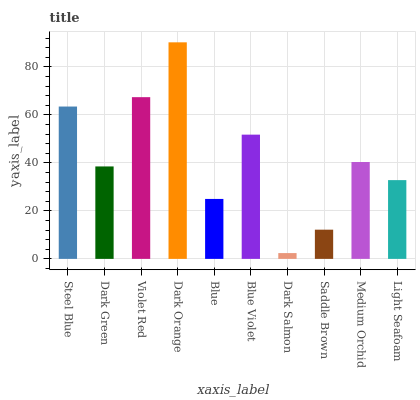Is Dark Salmon the minimum?
Answer yes or no. Yes. Is Dark Orange the maximum?
Answer yes or no. Yes. Is Dark Green the minimum?
Answer yes or no. No. Is Dark Green the maximum?
Answer yes or no. No. Is Steel Blue greater than Dark Green?
Answer yes or no. Yes. Is Dark Green less than Steel Blue?
Answer yes or no. Yes. Is Dark Green greater than Steel Blue?
Answer yes or no. No. Is Steel Blue less than Dark Green?
Answer yes or no. No. Is Medium Orchid the high median?
Answer yes or no. Yes. Is Dark Green the low median?
Answer yes or no. Yes. Is Violet Red the high median?
Answer yes or no. No. Is Steel Blue the low median?
Answer yes or no. No. 